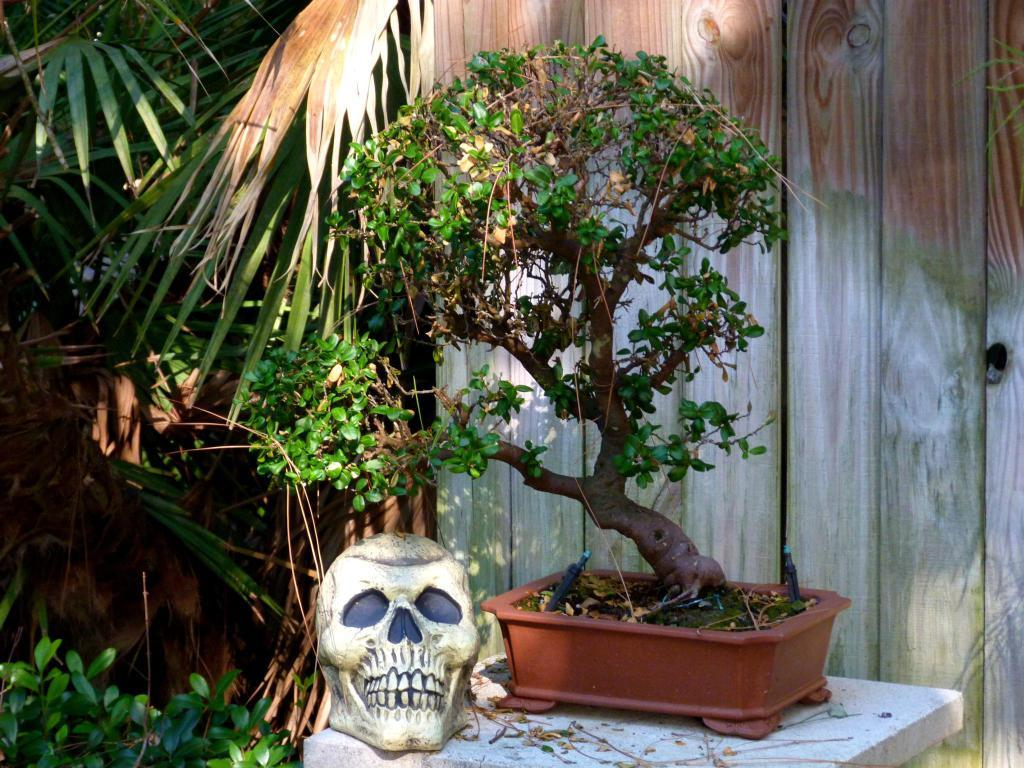What is placed on a stand in the image? There is a plant pot on a stand in the image. What type of structure can be seen in the image? There is a skull-like structure in the image. What is visible in the background of the image? There is a wall and trees in the background of the image. What is the purpose of the disgusting object in the image? There is no object described as "disgusting" in the image. The image features a plant pot on a stand and a skull-like structure, neither of which are described as disgusting. 